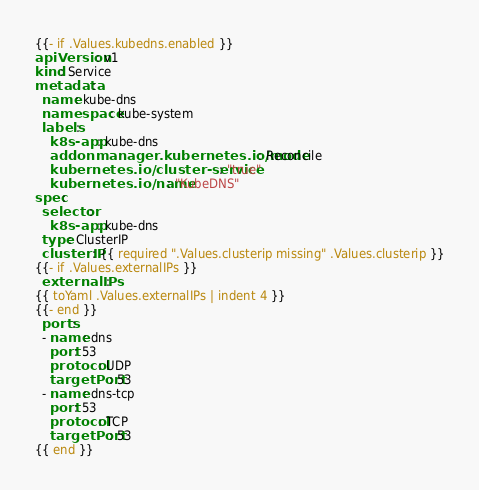Convert code to text. <code><loc_0><loc_0><loc_500><loc_500><_YAML_>{{- if .Values.kubedns.enabled }}
apiVersion: v1
kind: Service
metadata:
  name: kube-dns
  namespace: kube-system
  labels:
    k8s-app: kube-dns
    addonmanager.kubernetes.io/mode: Reconcile
    kubernetes.io/cluster-service: "true"
    kubernetes.io/name: "KubeDNS"
spec:
  selector:
    k8s-app: kube-dns
  type: ClusterIP
  clusterIP: {{ required ".Values.clusterip missing" .Values.clusterip }}
{{- if .Values.externalIPs }}
  externalIPs:
{{ toYaml .Values.externalIPs | indent 4 }}
{{- end }}
  ports:
  - name: dns
    port: 53
    protocol: UDP
    targetPort: 53
  - name: dns-tcp
    port: 53
    protocol: TCP
    targetPort: 53
{{ end }}
</code> 